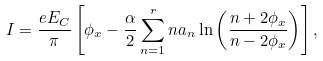Convert formula to latex. <formula><loc_0><loc_0><loc_500><loc_500>I = \frac { e E _ { C } } { \pi } \left [ \phi _ { x } - \frac { \alpha } { 2 } \sum _ { n = 1 } ^ { r } n a _ { n } \ln \left ( \frac { n + 2 \phi _ { x } } { n - 2 \phi _ { x } } \right ) \right ] ,</formula> 